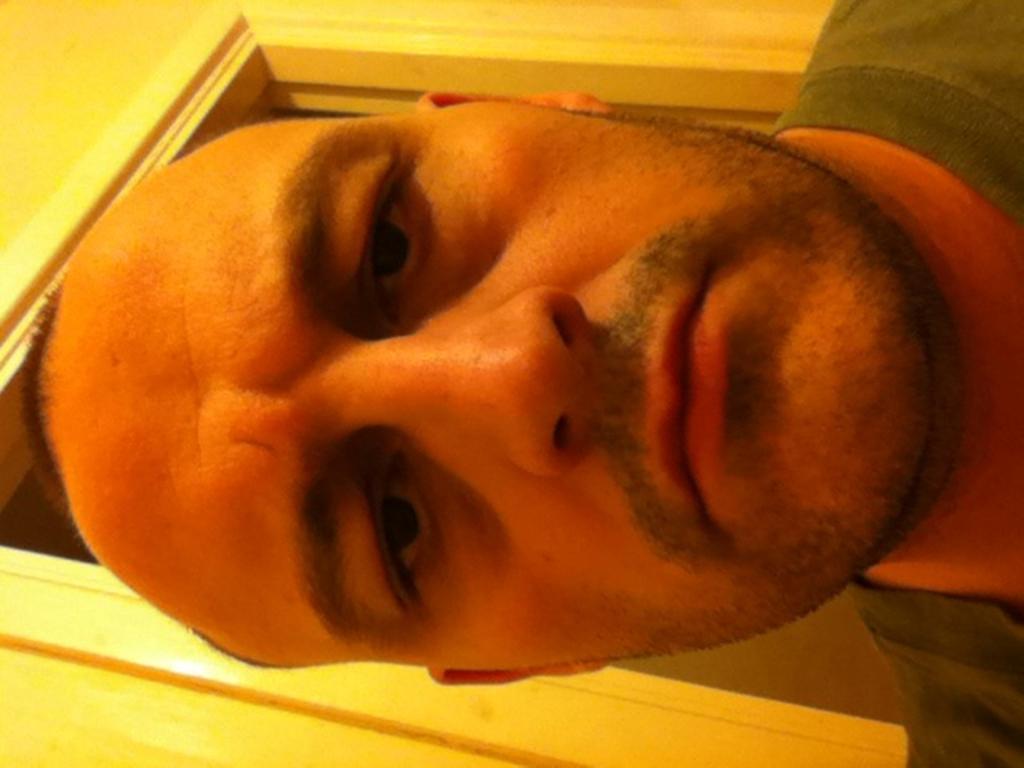Please provide a concise description of this image. In this image we can see a man. In the background there is a wall and we can see a door. 